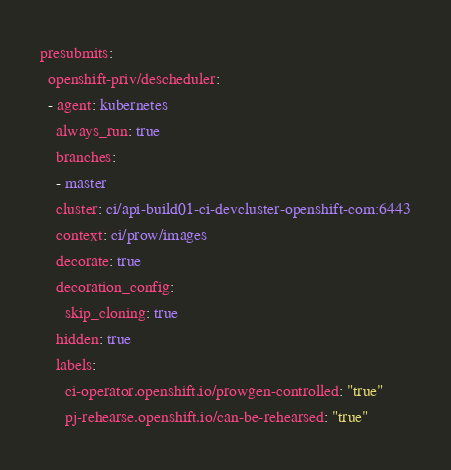<code> <loc_0><loc_0><loc_500><loc_500><_YAML_>presubmits:
  openshift-priv/descheduler:
  - agent: kubernetes
    always_run: true
    branches:
    - master
    cluster: ci/api-build01-ci-devcluster-openshift-com:6443
    context: ci/prow/images
    decorate: true
    decoration_config:
      skip_cloning: true
    hidden: true
    labels:
      ci-operator.openshift.io/prowgen-controlled: "true"
      pj-rehearse.openshift.io/can-be-rehearsed: "true"</code> 